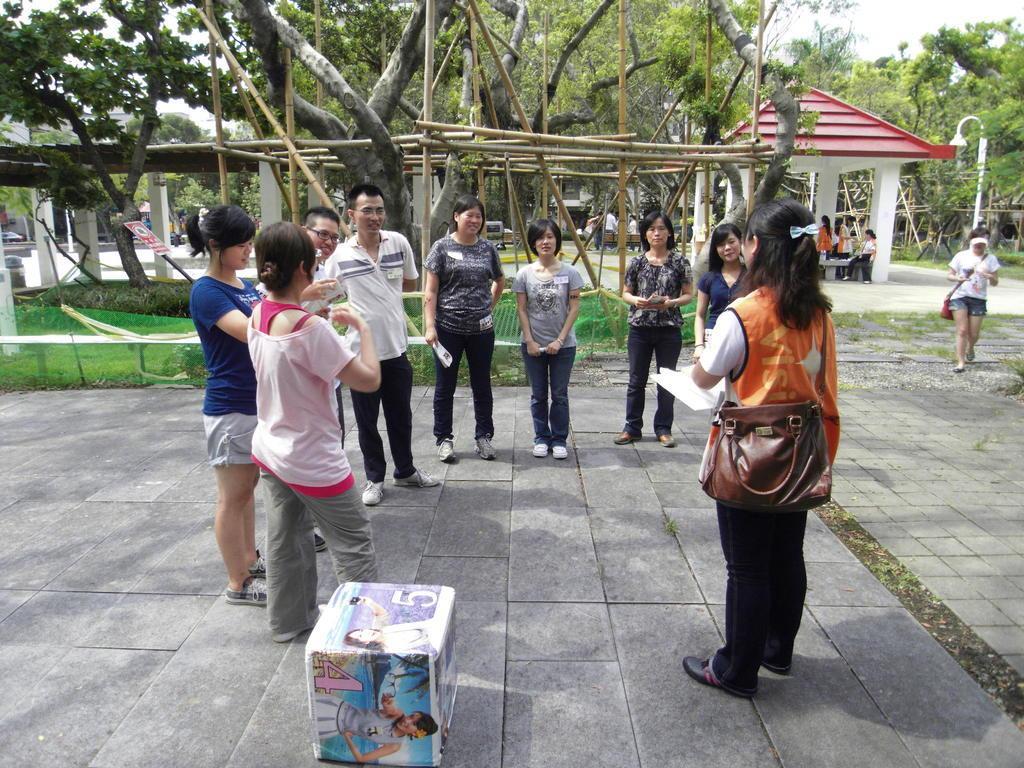In one or two sentences, can you explain what this image depicts? In this image we can see a group of people are standing on the ground, there are trees, there are pillars, here is the carton, there are persons sitting, there is the lamp, at above here is the sky. 